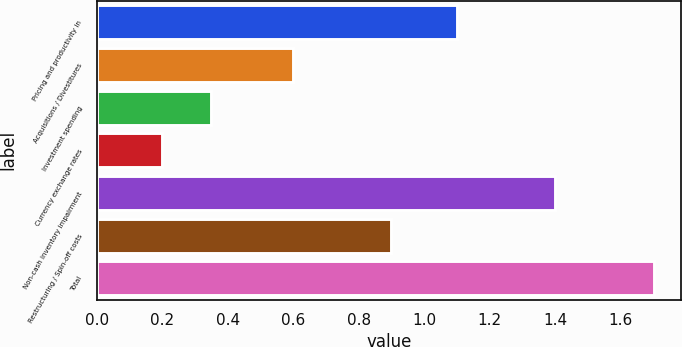Convert chart. <chart><loc_0><loc_0><loc_500><loc_500><bar_chart><fcel>Pricing and productivity in<fcel>Acquisitions / Divestitures<fcel>Investment spending<fcel>Currency exchange rates<fcel>Non-cash inventory impairment<fcel>Restructuring / Spin-off costs<fcel>Total<nl><fcel>1.1<fcel>0.6<fcel>0.35<fcel>0.2<fcel>1.4<fcel>0.9<fcel>1.7<nl></chart> 